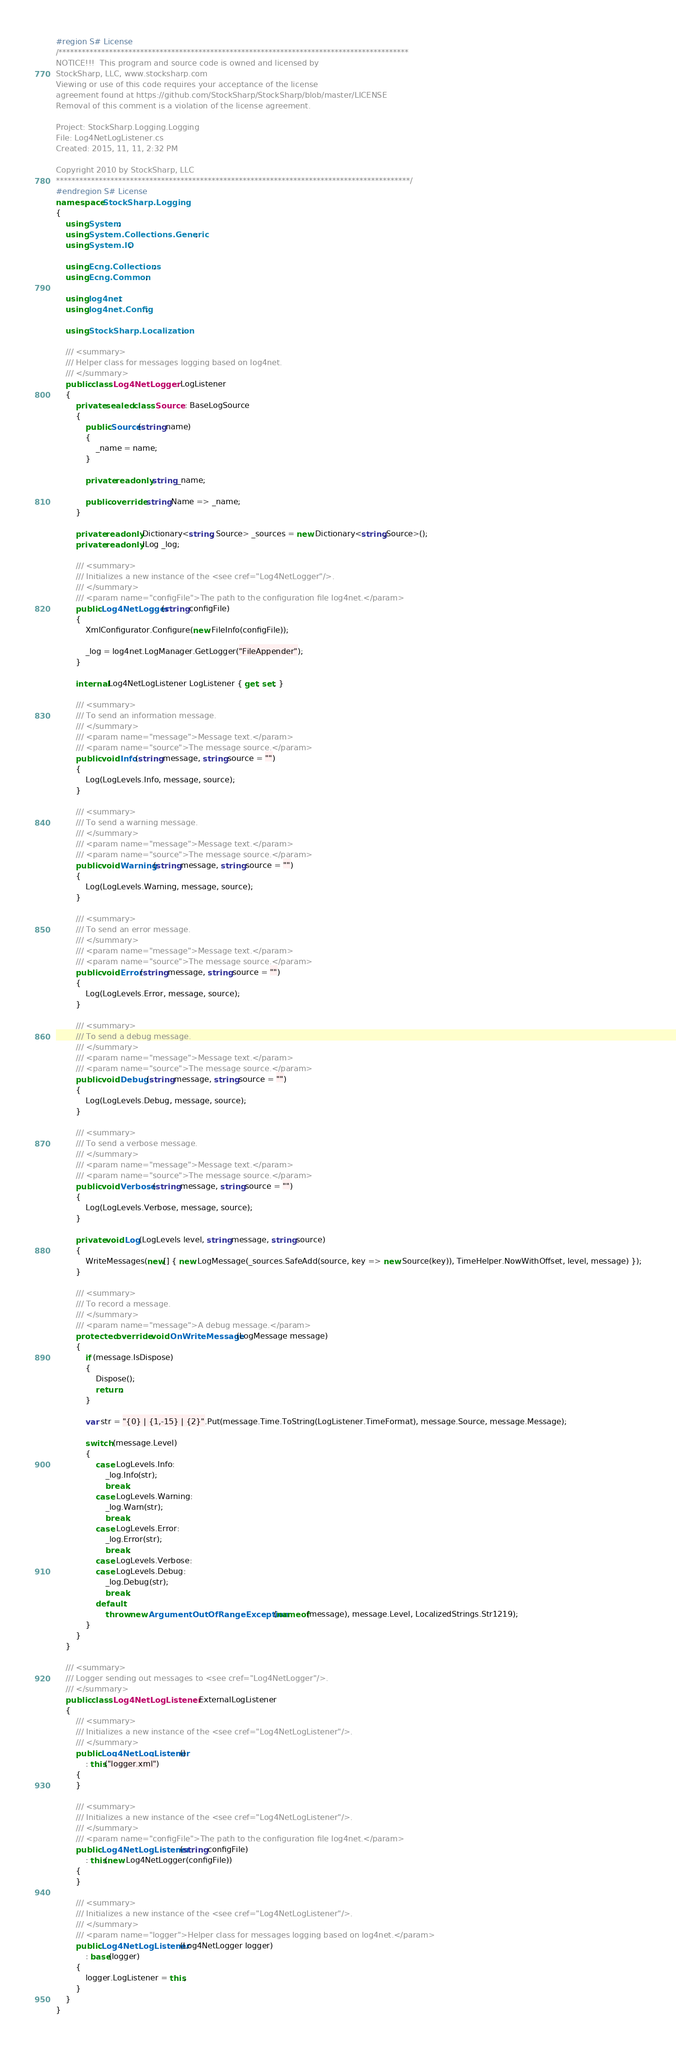<code> <loc_0><loc_0><loc_500><loc_500><_C#_>#region S# License
/******************************************************************************************
NOTICE!!!  This program and source code is owned and licensed by
StockSharp, LLC, www.stocksharp.com
Viewing or use of this code requires your acceptance of the license
agreement found at https://github.com/StockSharp/StockSharp/blob/master/LICENSE
Removal of this comment is a violation of the license agreement.

Project: StockSharp.Logging.Logging
File: Log4NetLogListener.cs
Created: 2015, 11, 11, 2:32 PM

Copyright 2010 by StockSharp, LLC
*******************************************************************************************/
#endregion S# License
namespace StockSharp.Logging
{
	using System;
	using System.Collections.Generic;
	using System.IO;

	using Ecng.Collections;
	using Ecng.Common;

	using log4net;
	using log4net.Config;

	using StockSharp.Localization;

	/// <summary>
	/// Helper class for messages logging based on log4net.
	/// </summary>
	public class Log4NetLogger : LogListener
	{
		private sealed class Source : BaseLogSource
		{
			public Source(string name)
			{
				_name = name;
			}

			private readonly string _name;

			public override string Name => _name;
		}

		private readonly Dictionary<string, Source> _sources = new Dictionary<string,Source>();
		private readonly ILog _log;

		/// <summary>
		/// Initializes a new instance of the <see cref="Log4NetLogger"/>.
		/// </summary>
		/// <param name="configFile">The path to the configuration file log4net.</param>
		public Log4NetLogger(string configFile)
		{
			XmlConfigurator.Configure(new FileInfo(configFile));

			_log = log4net.LogManager.GetLogger("FileAppender");
		}

		internal Log4NetLogListener LogListener { get; set; }

		/// <summary>
		/// To send an information message.
		/// </summary>
		/// <param name="message">Message text.</param>
		/// <param name="source">The message source.</param>
		public void Info(string message, string source = "")
		{
			Log(LogLevels.Info, message, source);
		}

		/// <summary>
		/// To send a warning message.
		/// </summary>
		/// <param name="message">Message text.</param>
		/// <param name="source">The message source.</param>
		public void Warning(string message, string source = "")
		{
			Log(LogLevels.Warning, message, source);
		}

		/// <summary>
		/// To send an error message.
		/// </summary>
		/// <param name="message">Message text.</param>
		/// <param name="source">The message source.</param>
		public void Error(string message, string source = "")
		{
			Log(LogLevels.Error, message, source);
		}

		/// <summary>
		/// To send a debug message.
		/// </summary>
		/// <param name="message">Message text.</param>
		/// <param name="source">The message source.</param>
		public void Debug(string message, string source = "")
		{
			Log(LogLevels.Debug, message, source);
		}

		/// <summary>
		/// To send a verbose message.
		/// </summary>
		/// <param name="message">Message text.</param>
		/// <param name="source">The message source.</param>
		public void Verbose(string message, string source = "")
		{
			Log(LogLevels.Verbose, message, source);
		}

		private void Log(LogLevels level, string message, string source)
		{
			WriteMessages(new[] { new LogMessage(_sources.SafeAdd(source, key => new Source(key)), TimeHelper.NowWithOffset, level, message) });
		}

		/// <summary>
		/// To record a message.
		/// </summary>
		/// <param name="message">A debug message.</param>
		protected override void OnWriteMessage(LogMessage message)
		{
			if (message.IsDispose)
			{
				Dispose();
				return;
			}

			var str = "{0} | {1,-15} | {2}".Put(message.Time.ToString(LogListener.TimeFormat), message.Source, message.Message);

			switch (message.Level)
			{
				case LogLevels.Info:
					_log.Info(str);
					break;
				case LogLevels.Warning:
					_log.Warn(str);
					break;
				case LogLevels.Error:
					_log.Error(str);
					break;
				case LogLevels.Verbose:
				case LogLevels.Debug:
					_log.Debug(str);
					break;
				default:
					throw new ArgumentOutOfRangeException(nameof(message), message.Level, LocalizedStrings.Str1219);
			}
		}
	}

	/// <summary>
	/// Logger sending out messages to <see cref="Log4NetLogger"/>.
	/// </summary>
	public class Log4NetLogListener : ExternalLogListener
	{
		/// <summary>
		/// Initializes a new instance of the <see cref="Log4NetLogListener"/>.
		/// </summary>
		public Log4NetLogListener()
			: this("logger.xml")
		{
		}

		/// <summary>
		/// Initializes a new instance of the <see cref="Log4NetLogListener"/>.
		/// </summary>
		/// <param name="configFile">The path to the configuration file log4net.</param>
		public Log4NetLogListener(string configFile)
			: this(new Log4NetLogger(configFile))
		{
		}

		/// <summary>
		/// Initializes a new instance of the <see cref="Log4NetLogListener"/>.
		/// </summary>
		/// <param name="logger">Helper class for messages logging based on log4net.</param>
		public Log4NetLogListener(Log4NetLogger logger)
			: base(logger)
		{
			logger.LogListener = this;
		}
	}
}</code> 